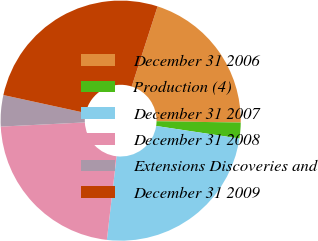Convert chart. <chart><loc_0><loc_0><loc_500><loc_500><pie_chart><fcel>December 31 2006<fcel>Production (4)<fcel>December 31 2007<fcel>December 31 2008<fcel>Extensions Discoveries and<fcel>December 31 2009<nl><fcel>20.28%<fcel>2.12%<fcel>24.46%<fcel>22.37%<fcel>4.21%<fcel>26.55%<nl></chart> 